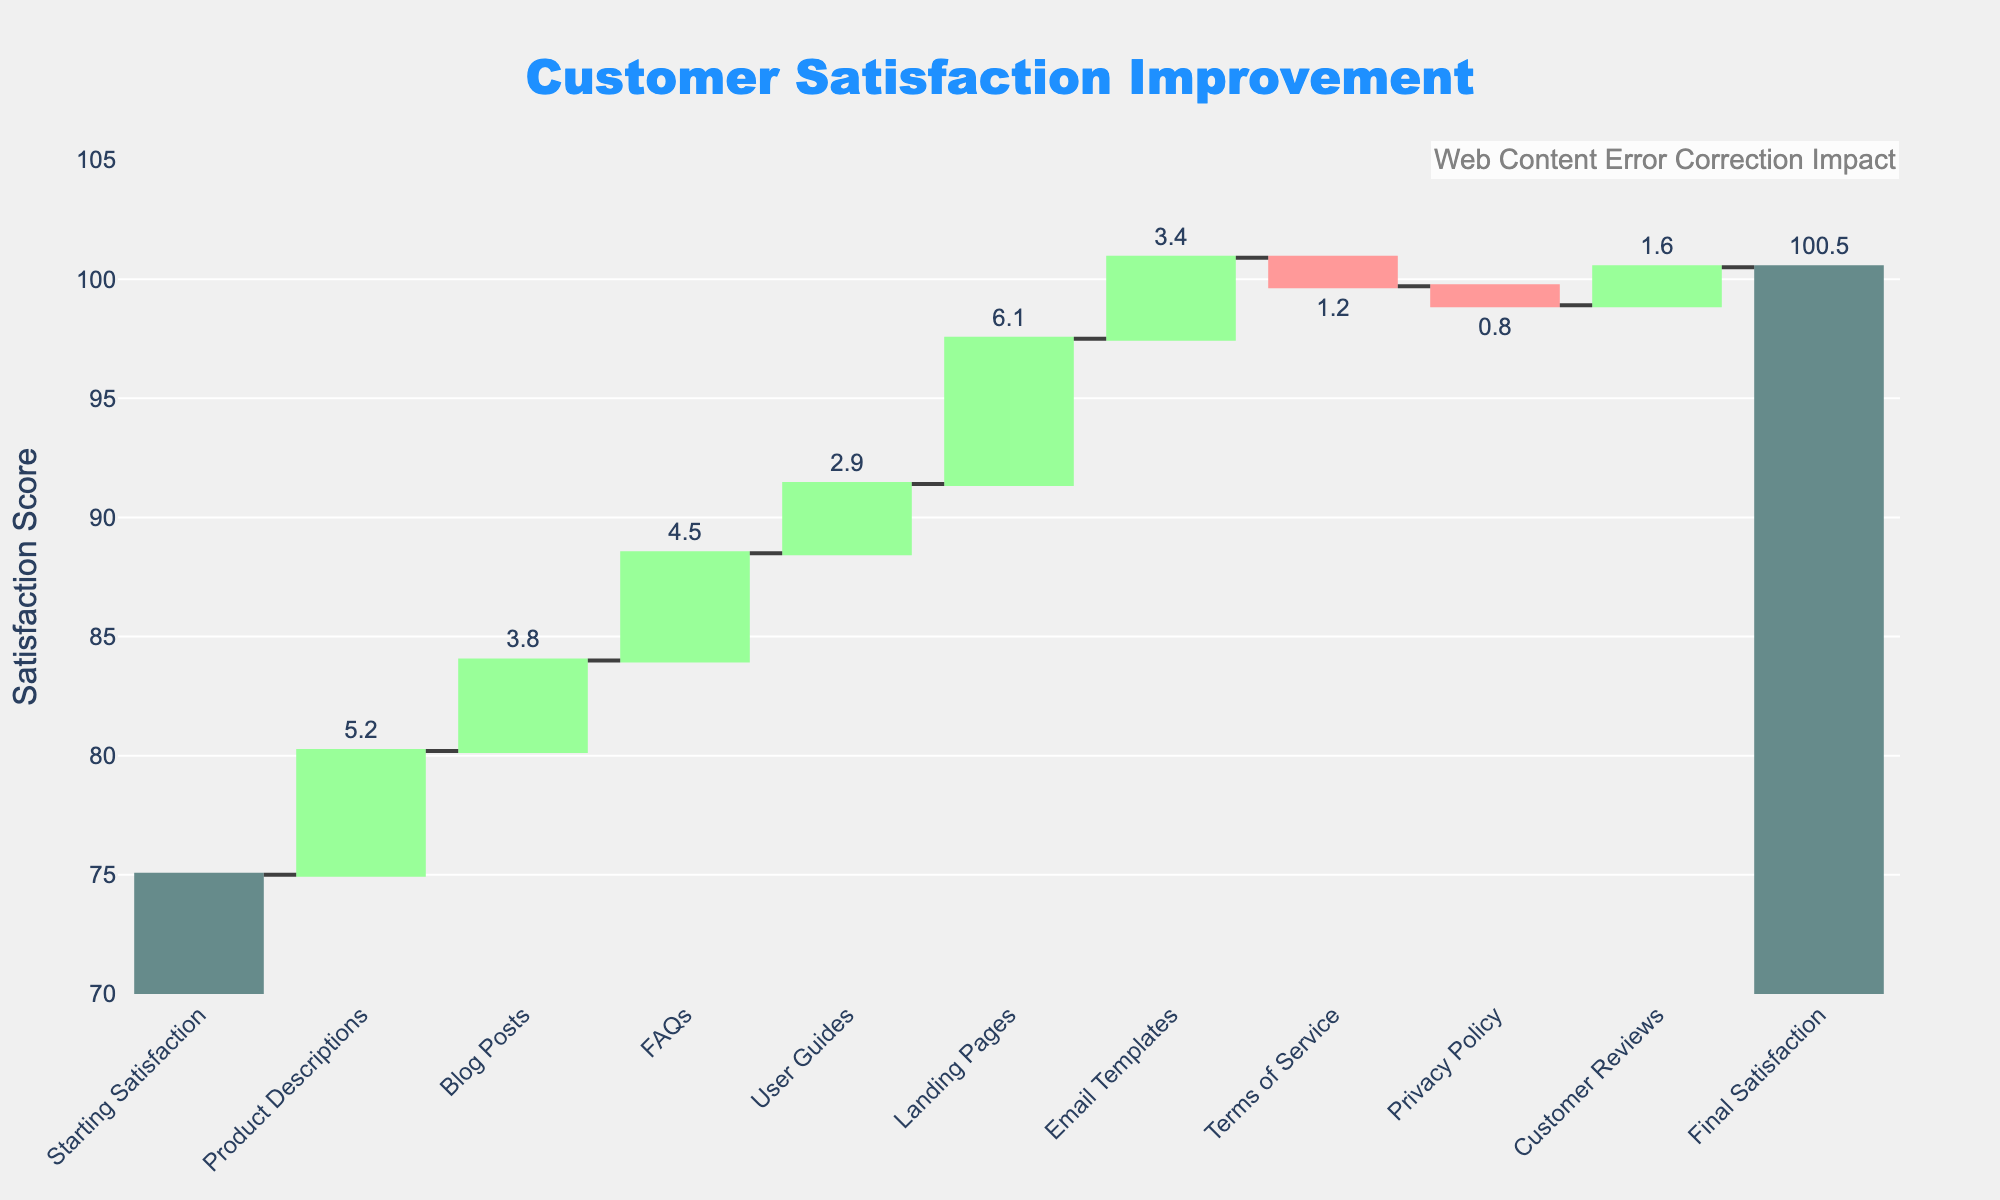How does the customer satisfaction improvement start and end? The figure shows that customer satisfaction starts at a score of 75 and ends at a score of 100.5 after improvements across various content types.
Answer: Starts at 75 and ends at 100.5 Which content type contributed the least to customer satisfaction? Look at the values for each content type contribution. The Privacy Policy had the smallest positive contribution at -0.8.
Answer: Privacy Policy How much did the Product Descriptions improve customer satisfaction? The figure shows a positive contribution from Product Descriptions. The value is +5.2.
Answer: +5.2 What is the impact of Terms of Service on customer satisfaction? The figure indicates that the Terms of Service had a negative impact on customer satisfaction, decreasing it by 1.2 points.
Answer: -1.2 Which content types have a negative impact on customer satisfaction? Check for negative bars in the figure. Terms of Service and Privacy Policy both have negative impacts.
Answer: Terms of Service, Privacy Policy Which content type had the highest positive impact on customer satisfaction? The content type with the highest positive value is the Landing Pages with an increase of 6.1 points.
Answer: Landing Pages What is the total improvement in customer satisfaction from Blog Posts and FAQs combined? Sum the improvement values for Blog Posts (+3.8) and FAQs (+4.5). The total is 3.8 + 4.5 = 8.3.
Answer: +8.3 How does the satisfaction change due to User Guides compare to Customer Reviews? User Guides show an improvement of +2.9, while Customer Reviews show an improvement of +1.6. Thus, User Guides have a higher impact.
Answer: User Guides have a higher impact What is the combined improvement in customer satisfaction of all content types except the negative ones? Sum all positive contributions: Product Descriptions, Blog Posts, FAQs, User Guides, Landing Pages, Email Templates, Customer Reviews. (5.2 + 3.8 + 4.5 + 2.9 + 6.1 + 3.4 + 1.6 = 27.5).
Answer: +27.5 How many types of content are analyzed in the figure? Count all unique content types from the figure. There are nine content types analyzed.
Answer: Nine 